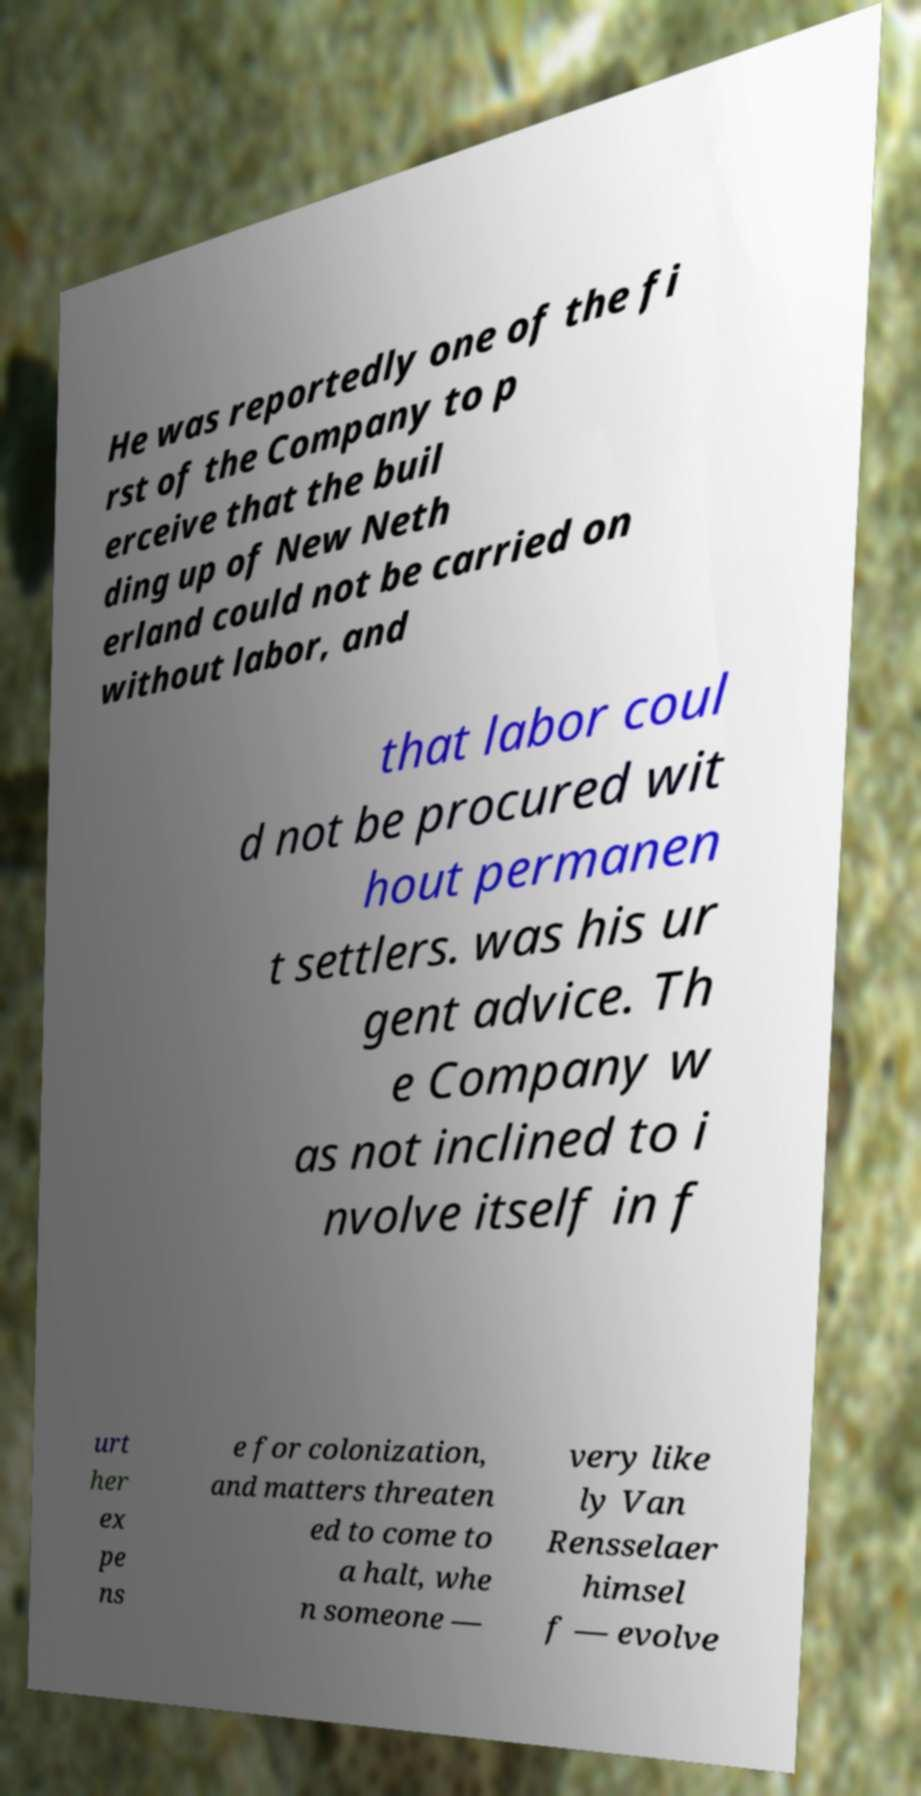Can you read and provide the text displayed in the image?This photo seems to have some interesting text. Can you extract and type it out for me? He was reportedly one of the fi rst of the Company to p erceive that the buil ding up of New Neth erland could not be carried on without labor, and that labor coul d not be procured wit hout permanen t settlers. was his ur gent advice. Th e Company w as not inclined to i nvolve itself in f urt her ex pe ns e for colonization, and matters threaten ed to come to a halt, whe n someone — very like ly Van Rensselaer himsel f — evolve 